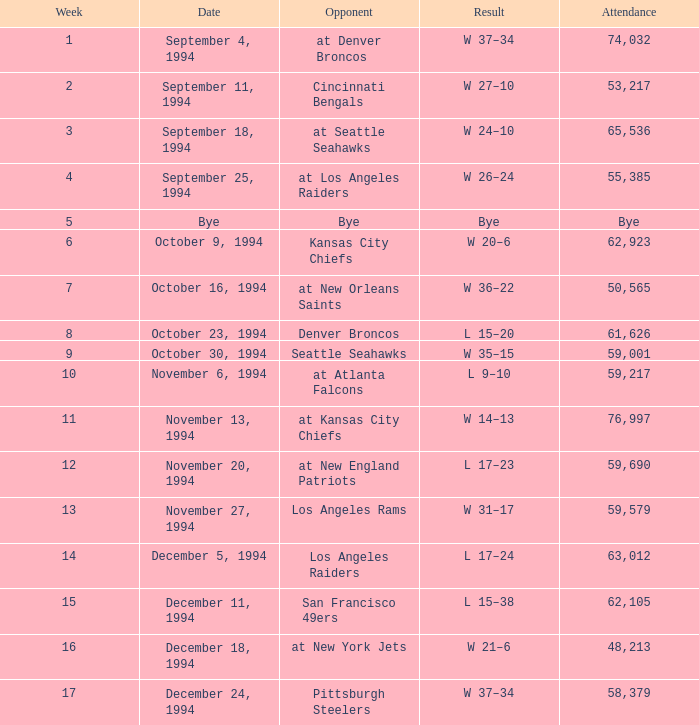In the match featuring the pittsburgh steelers, what was the number of spectators? 58379.0. 